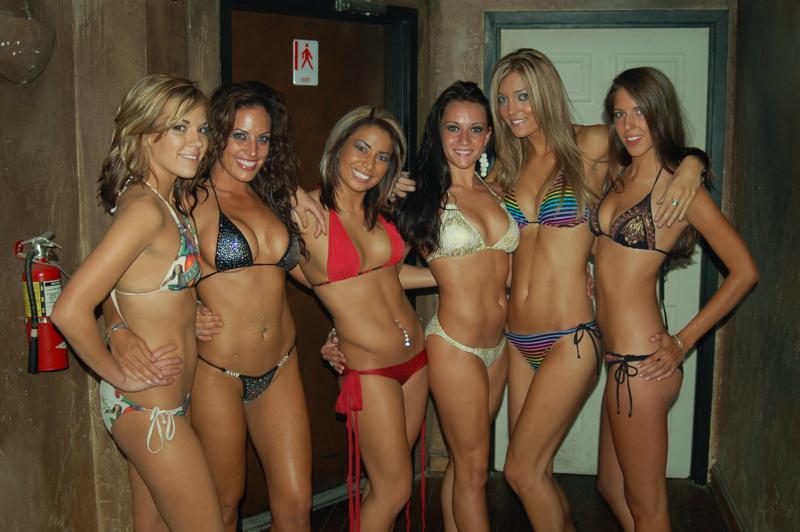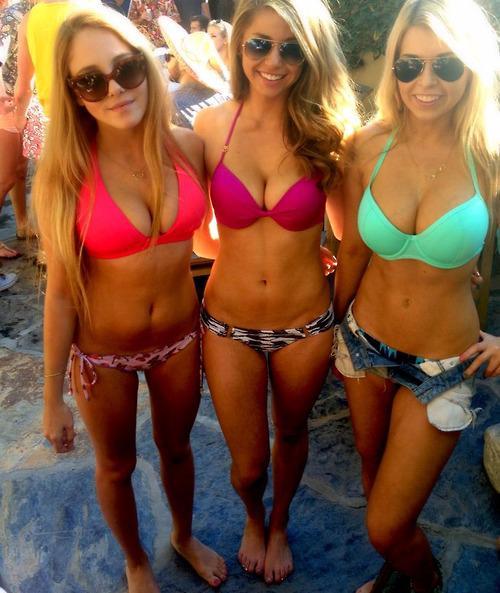The first image is the image on the left, the second image is the image on the right. Assess this claim about the two images: "There are 6 women lined up for a photo in the left image.". Correct or not? Answer yes or no. Yes. The first image is the image on the left, the second image is the image on the right. For the images shown, is this caption "The left and right image contains a total of 13 women in bikinis." true? Answer yes or no. No. 